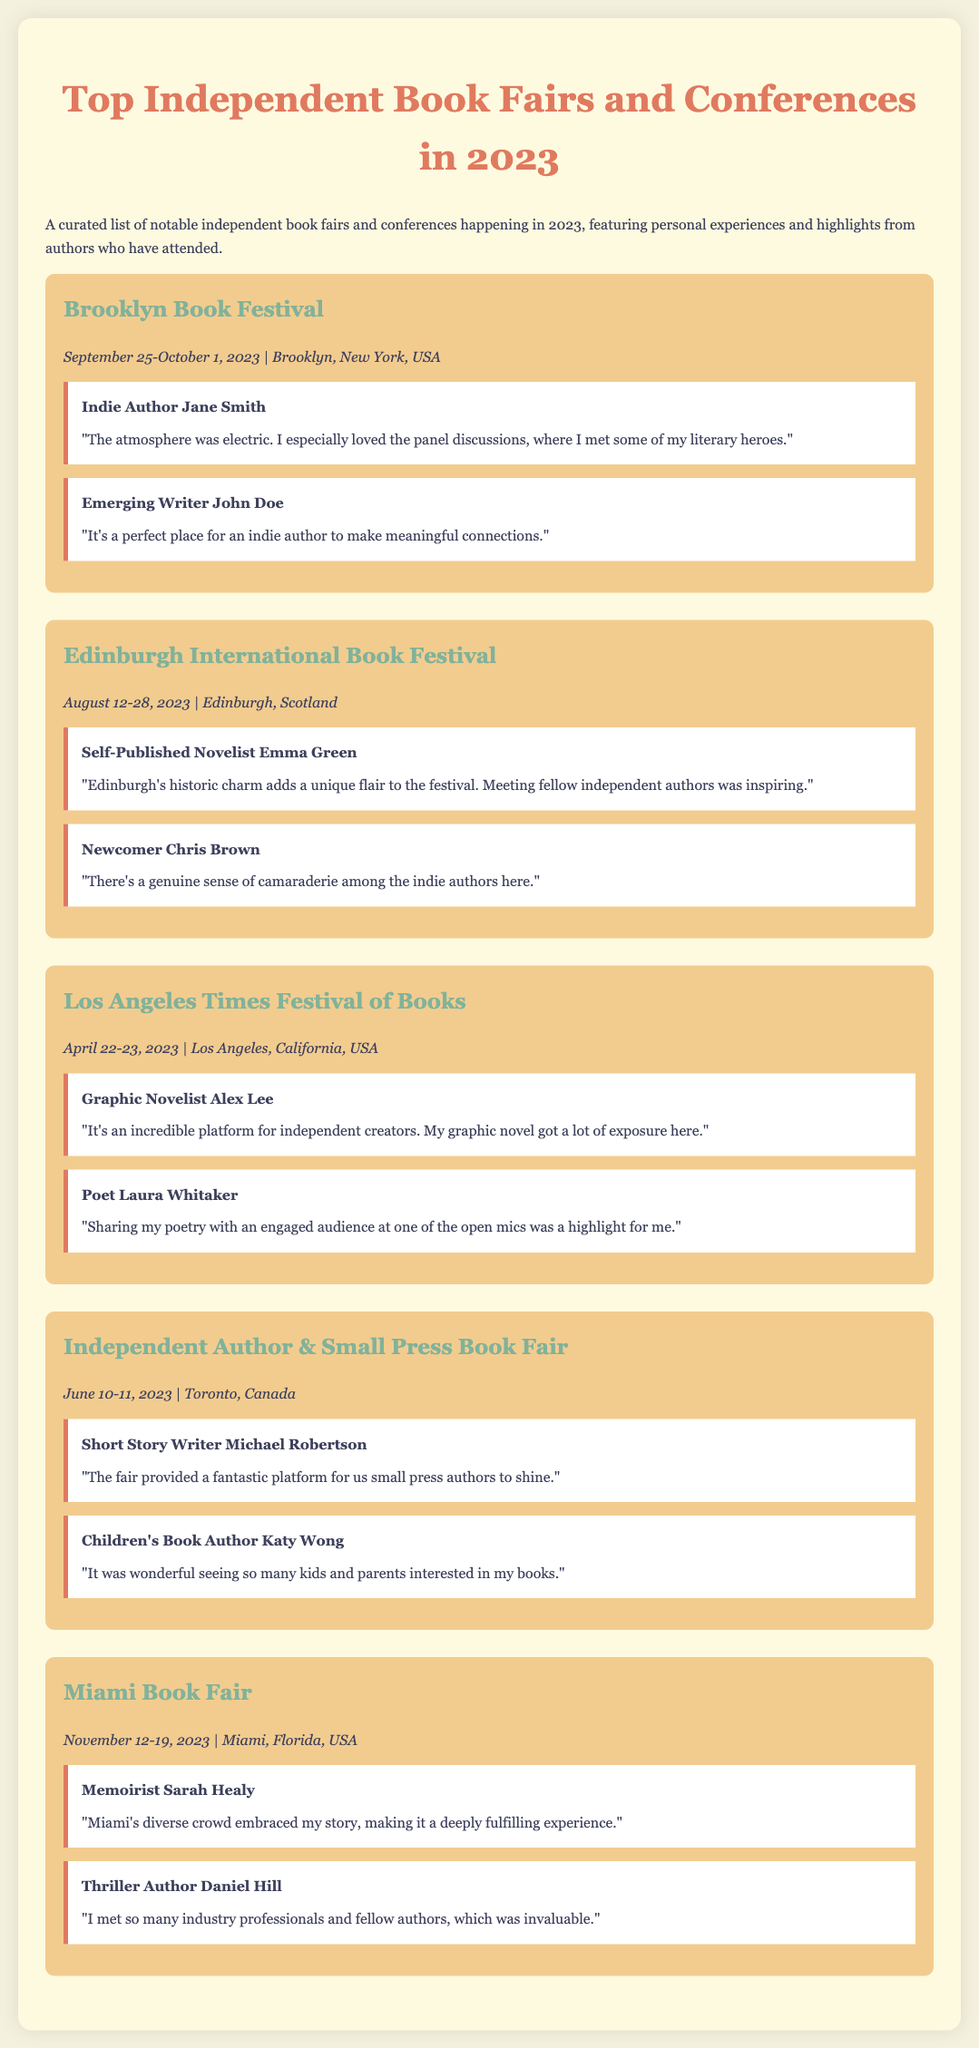What is the location of the Brooklyn Book Festival? The Brooklyn Book Festival takes place in Brooklyn, New York, USA.
Answer: Brooklyn, New York, USA When is the Los Angeles Times Festival of Books held? The Los Angeles Times Festival of Books is held on April 22-23, 2023.
Answer: April 22-23, 2023 Who is the author that highlighted the atmosphere at the Brooklyn Book Festival? Indie Author Jane Smith expressed that the atmosphere was electric at the Brooklyn Book Festival.
Answer: Jane Smith What type of authors attend the Independent Author & Small Press Book Fair? The event features small press authors.
Answer: Small press authors Which festival is known for its historic charm, according to Emma Green? Emma Green highlighted the historic charm of the Edinburgh International Book Festival.
Answer: Edinburgh International Book Festival Which author mentioned that Miami's diverse crowd embraced her story? Memoirist Sarah Healy noted that Miami's diverse crowd embraced her story.
Answer: Sarah Healy What is a common sentiment expressed by authors at the Edinburgh International Book Festival? The common sentiment among authors at the festival is a sense of camaraderie.
Answer: Camaraderie How many highlights are featured for the Miami Book Fair? There are two highlights featured for the Miami Book Fair.
Answer: Two highlights 